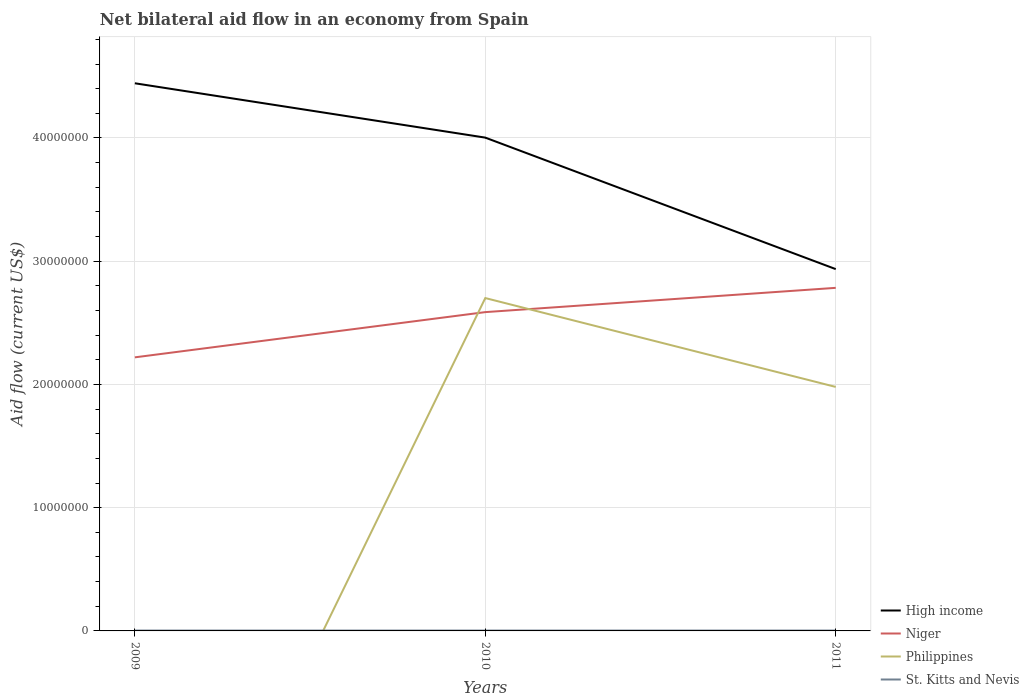How many different coloured lines are there?
Your answer should be very brief. 4. Does the line corresponding to High income intersect with the line corresponding to St. Kitts and Nevis?
Your answer should be compact. No. Across all years, what is the maximum net bilateral aid flow in High income?
Ensure brevity in your answer.  2.94e+07. What is the total net bilateral aid flow in Philippines in the graph?
Ensure brevity in your answer.  7.21e+06. What is the difference between the highest and the second highest net bilateral aid flow in Philippines?
Your answer should be compact. 2.70e+07. How many lines are there?
Provide a short and direct response. 4. How many years are there in the graph?
Offer a terse response. 3. What is the difference between two consecutive major ticks on the Y-axis?
Offer a very short reply. 1.00e+07. Are the values on the major ticks of Y-axis written in scientific E-notation?
Keep it short and to the point. No. Does the graph contain any zero values?
Provide a short and direct response. Yes. Where does the legend appear in the graph?
Your response must be concise. Bottom right. What is the title of the graph?
Your answer should be very brief. Net bilateral aid flow in an economy from Spain. What is the label or title of the X-axis?
Make the answer very short. Years. What is the label or title of the Y-axis?
Offer a terse response. Aid flow (current US$). What is the Aid flow (current US$) in High income in 2009?
Keep it short and to the point. 4.44e+07. What is the Aid flow (current US$) in Niger in 2009?
Offer a very short reply. 2.22e+07. What is the Aid flow (current US$) in Philippines in 2009?
Offer a terse response. 0. What is the Aid flow (current US$) in St. Kitts and Nevis in 2009?
Your response must be concise. 3.00e+04. What is the Aid flow (current US$) of High income in 2010?
Your answer should be compact. 4.00e+07. What is the Aid flow (current US$) of Niger in 2010?
Ensure brevity in your answer.  2.59e+07. What is the Aid flow (current US$) in Philippines in 2010?
Ensure brevity in your answer.  2.70e+07. What is the Aid flow (current US$) of St. Kitts and Nevis in 2010?
Keep it short and to the point. 3.00e+04. What is the Aid flow (current US$) in High income in 2011?
Provide a succinct answer. 2.94e+07. What is the Aid flow (current US$) of Niger in 2011?
Give a very brief answer. 2.78e+07. What is the Aid flow (current US$) in Philippines in 2011?
Provide a succinct answer. 1.98e+07. What is the Aid flow (current US$) of St. Kitts and Nevis in 2011?
Make the answer very short. 3.00e+04. Across all years, what is the maximum Aid flow (current US$) in High income?
Your response must be concise. 4.44e+07. Across all years, what is the maximum Aid flow (current US$) of Niger?
Offer a very short reply. 2.78e+07. Across all years, what is the maximum Aid flow (current US$) of Philippines?
Your answer should be very brief. 2.70e+07. Across all years, what is the minimum Aid flow (current US$) of High income?
Ensure brevity in your answer.  2.94e+07. Across all years, what is the minimum Aid flow (current US$) in Niger?
Ensure brevity in your answer.  2.22e+07. Across all years, what is the minimum Aid flow (current US$) in Philippines?
Keep it short and to the point. 0. What is the total Aid flow (current US$) of High income in the graph?
Your answer should be very brief. 1.14e+08. What is the total Aid flow (current US$) in Niger in the graph?
Keep it short and to the point. 7.59e+07. What is the total Aid flow (current US$) of Philippines in the graph?
Provide a succinct answer. 4.68e+07. What is the total Aid flow (current US$) of St. Kitts and Nevis in the graph?
Ensure brevity in your answer.  9.00e+04. What is the difference between the Aid flow (current US$) of High income in 2009 and that in 2010?
Make the answer very short. 4.41e+06. What is the difference between the Aid flow (current US$) of Niger in 2009 and that in 2010?
Give a very brief answer. -3.67e+06. What is the difference between the Aid flow (current US$) in High income in 2009 and that in 2011?
Provide a succinct answer. 1.51e+07. What is the difference between the Aid flow (current US$) in Niger in 2009 and that in 2011?
Offer a terse response. -5.64e+06. What is the difference between the Aid flow (current US$) of High income in 2010 and that in 2011?
Your answer should be very brief. 1.07e+07. What is the difference between the Aid flow (current US$) of Niger in 2010 and that in 2011?
Ensure brevity in your answer.  -1.97e+06. What is the difference between the Aid flow (current US$) of Philippines in 2010 and that in 2011?
Your answer should be compact. 7.21e+06. What is the difference between the Aid flow (current US$) in High income in 2009 and the Aid flow (current US$) in Niger in 2010?
Your answer should be very brief. 1.86e+07. What is the difference between the Aid flow (current US$) of High income in 2009 and the Aid flow (current US$) of Philippines in 2010?
Make the answer very short. 1.74e+07. What is the difference between the Aid flow (current US$) of High income in 2009 and the Aid flow (current US$) of St. Kitts and Nevis in 2010?
Offer a very short reply. 4.44e+07. What is the difference between the Aid flow (current US$) of Niger in 2009 and the Aid flow (current US$) of Philippines in 2010?
Your answer should be compact. -4.81e+06. What is the difference between the Aid flow (current US$) in Niger in 2009 and the Aid flow (current US$) in St. Kitts and Nevis in 2010?
Keep it short and to the point. 2.22e+07. What is the difference between the Aid flow (current US$) in High income in 2009 and the Aid flow (current US$) in Niger in 2011?
Your response must be concise. 1.66e+07. What is the difference between the Aid flow (current US$) in High income in 2009 and the Aid flow (current US$) in Philippines in 2011?
Offer a terse response. 2.46e+07. What is the difference between the Aid flow (current US$) of High income in 2009 and the Aid flow (current US$) of St. Kitts and Nevis in 2011?
Your answer should be very brief. 4.44e+07. What is the difference between the Aid flow (current US$) of Niger in 2009 and the Aid flow (current US$) of Philippines in 2011?
Your answer should be very brief. 2.40e+06. What is the difference between the Aid flow (current US$) of Niger in 2009 and the Aid flow (current US$) of St. Kitts and Nevis in 2011?
Your response must be concise. 2.22e+07. What is the difference between the Aid flow (current US$) of High income in 2010 and the Aid flow (current US$) of Niger in 2011?
Your answer should be compact. 1.22e+07. What is the difference between the Aid flow (current US$) of High income in 2010 and the Aid flow (current US$) of Philippines in 2011?
Give a very brief answer. 2.02e+07. What is the difference between the Aid flow (current US$) of High income in 2010 and the Aid flow (current US$) of St. Kitts and Nevis in 2011?
Keep it short and to the point. 4.00e+07. What is the difference between the Aid flow (current US$) of Niger in 2010 and the Aid flow (current US$) of Philippines in 2011?
Offer a very short reply. 6.07e+06. What is the difference between the Aid flow (current US$) in Niger in 2010 and the Aid flow (current US$) in St. Kitts and Nevis in 2011?
Your response must be concise. 2.58e+07. What is the difference between the Aid flow (current US$) in Philippines in 2010 and the Aid flow (current US$) in St. Kitts and Nevis in 2011?
Provide a short and direct response. 2.70e+07. What is the average Aid flow (current US$) of High income per year?
Offer a terse response. 3.79e+07. What is the average Aid flow (current US$) of Niger per year?
Ensure brevity in your answer.  2.53e+07. What is the average Aid flow (current US$) of Philippines per year?
Your response must be concise. 1.56e+07. What is the average Aid flow (current US$) of St. Kitts and Nevis per year?
Your answer should be very brief. 3.00e+04. In the year 2009, what is the difference between the Aid flow (current US$) in High income and Aid flow (current US$) in Niger?
Your answer should be very brief. 2.22e+07. In the year 2009, what is the difference between the Aid flow (current US$) in High income and Aid flow (current US$) in St. Kitts and Nevis?
Provide a succinct answer. 4.44e+07. In the year 2009, what is the difference between the Aid flow (current US$) of Niger and Aid flow (current US$) of St. Kitts and Nevis?
Make the answer very short. 2.22e+07. In the year 2010, what is the difference between the Aid flow (current US$) in High income and Aid flow (current US$) in Niger?
Offer a terse response. 1.42e+07. In the year 2010, what is the difference between the Aid flow (current US$) in High income and Aid flow (current US$) in Philippines?
Keep it short and to the point. 1.30e+07. In the year 2010, what is the difference between the Aid flow (current US$) of High income and Aid flow (current US$) of St. Kitts and Nevis?
Offer a very short reply. 4.00e+07. In the year 2010, what is the difference between the Aid flow (current US$) of Niger and Aid flow (current US$) of Philippines?
Provide a short and direct response. -1.14e+06. In the year 2010, what is the difference between the Aid flow (current US$) in Niger and Aid flow (current US$) in St. Kitts and Nevis?
Your answer should be very brief. 2.58e+07. In the year 2010, what is the difference between the Aid flow (current US$) of Philippines and Aid flow (current US$) of St. Kitts and Nevis?
Offer a terse response. 2.70e+07. In the year 2011, what is the difference between the Aid flow (current US$) of High income and Aid flow (current US$) of Niger?
Your answer should be very brief. 1.52e+06. In the year 2011, what is the difference between the Aid flow (current US$) in High income and Aid flow (current US$) in Philippines?
Provide a short and direct response. 9.56e+06. In the year 2011, what is the difference between the Aid flow (current US$) in High income and Aid flow (current US$) in St. Kitts and Nevis?
Give a very brief answer. 2.93e+07. In the year 2011, what is the difference between the Aid flow (current US$) in Niger and Aid flow (current US$) in Philippines?
Your response must be concise. 8.04e+06. In the year 2011, what is the difference between the Aid flow (current US$) of Niger and Aid flow (current US$) of St. Kitts and Nevis?
Give a very brief answer. 2.78e+07. In the year 2011, what is the difference between the Aid flow (current US$) in Philippines and Aid flow (current US$) in St. Kitts and Nevis?
Your answer should be compact. 1.98e+07. What is the ratio of the Aid flow (current US$) in High income in 2009 to that in 2010?
Your answer should be very brief. 1.11. What is the ratio of the Aid flow (current US$) in Niger in 2009 to that in 2010?
Your answer should be very brief. 0.86. What is the ratio of the Aid flow (current US$) in St. Kitts and Nevis in 2009 to that in 2010?
Your answer should be very brief. 1. What is the ratio of the Aid flow (current US$) in High income in 2009 to that in 2011?
Your answer should be compact. 1.51. What is the ratio of the Aid flow (current US$) in Niger in 2009 to that in 2011?
Offer a terse response. 0.8. What is the ratio of the Aid flow (current US$) of St. Kitts and Nevis in 2009 to that in 2011?
Offer a very short reply. 1. What is the ratio of the Aid flow (current US$) of High income in 2010 to that in 2011?
Provide a succinct answer. 1.36. What is the ratio of the Aid flow (current US$) in Niger in 2010 to that in 2011?
Offer a very short reply. 0.93. What is the ratio of the Aid flow (current US$) in Philippines in 2010 to that in 2011?
Your answer should be compact. 1.36. What is the ratio of the Aid flow (current US$) of St. Kitts and Nevis in 2010 to that in 2011?
Provide a short and direct response. 1. What is the difference between the highest and the second highest Aid flow (current US$) of High income?
Your answer should be compact. 4.41e+06. What is the difference between the highest and the second highest Aid flow (current US$) in Niger?
Provide a succinct answer. 1.97e+06. What is the difference between the highest and the lowest Aid flow (current US$) in High income?
Your response must be concise. 1.51e+07. What is the difference between the highest and the lowest Aid flow (current US$) in Niger?
Offer a very short reply. 5.64e+06. What is the difference between the highest and the lowest Aid flow (current US$) in Philippines?
Make the answer very short. 2.70e+07. 